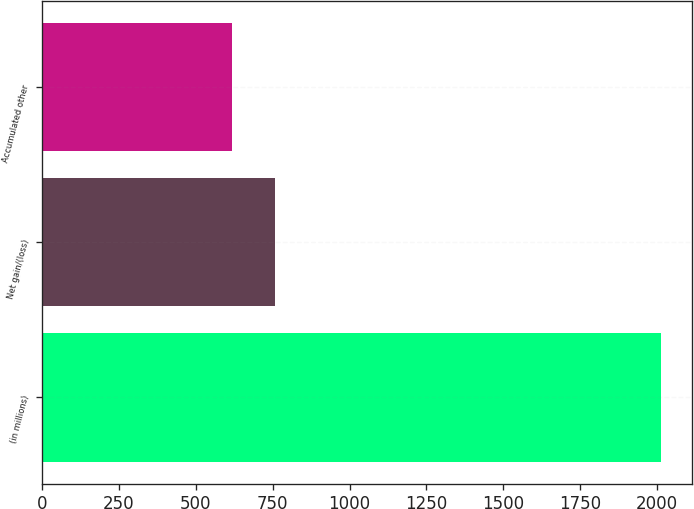<chart> <loc_0><loc_0><loc_500><loc_500><bar_chart><fcel>(in millions)<fcel>Net gain/(loss)<fcel>Accumulated other<nl><fcel>2014<fcel>756.7<fcel>617<nl></chart> 